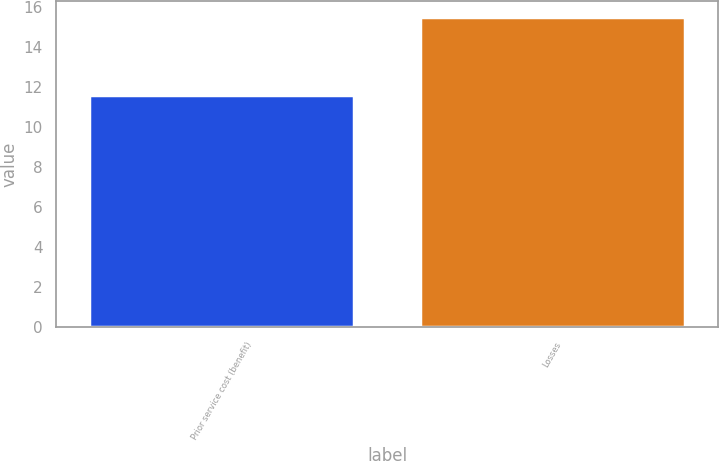Convert chart to OTSL. <chart><loc_0><loc_0><loc_500><loc_500><bar_chart><fcel>Prior service cost (benefit)<fcel>Losses<nl><fcel>11.6<fcel>15.5<nl></chart> 